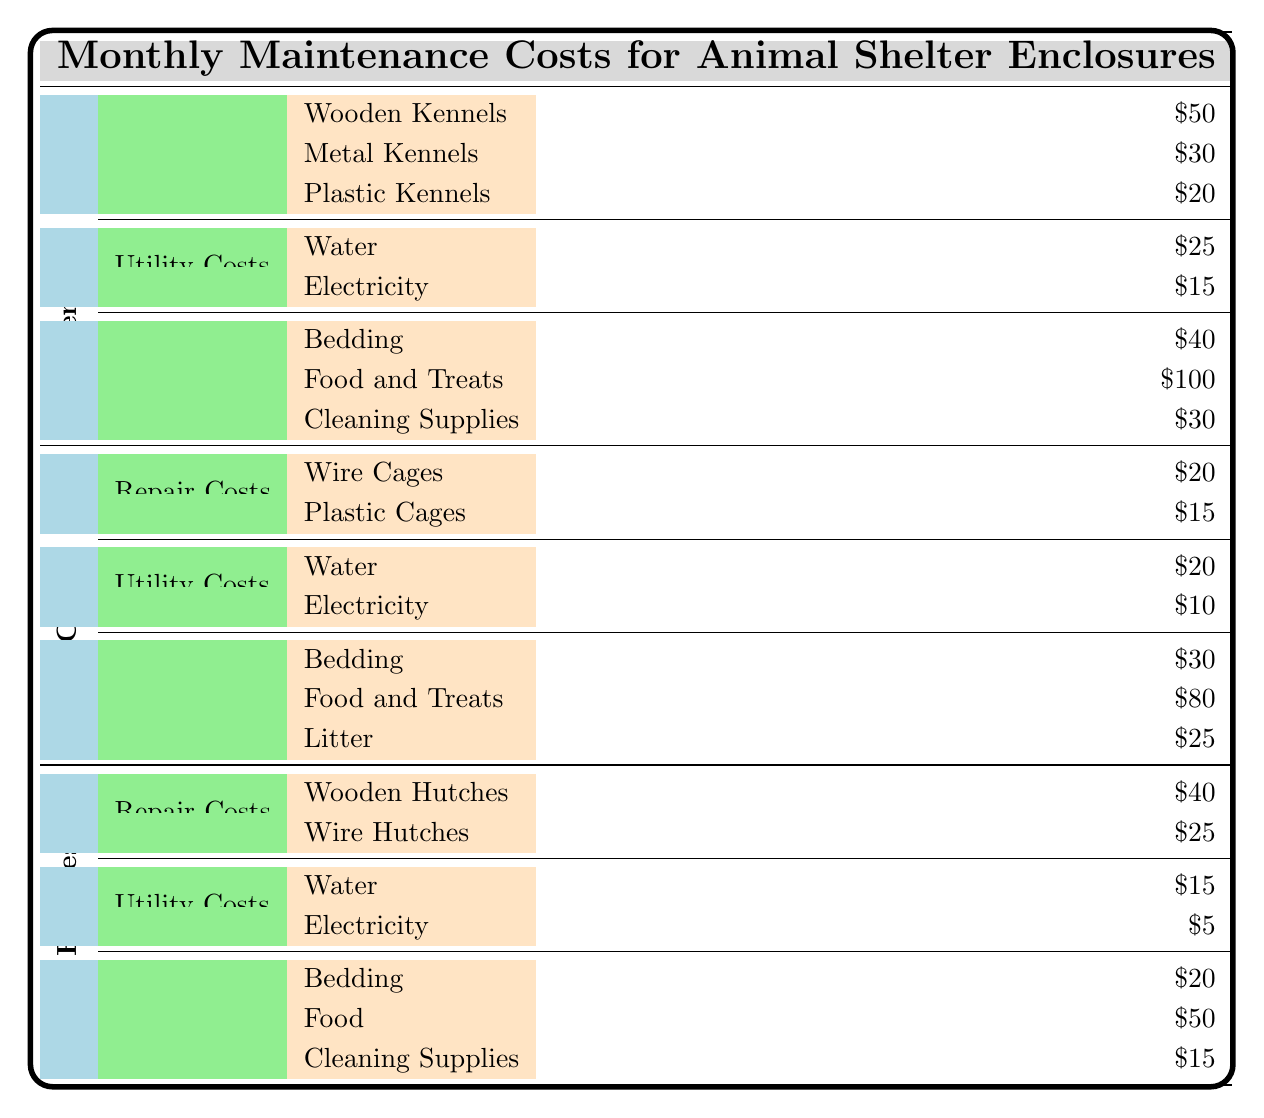What are the repair costs for Wooden Kennels? The repair cost for Wooden Kennels is listed directly in the table under Dog Kennels, specifically as $50.
Answer: $50 What is the total Utility Cost for Cat Cages? To find the total Utility Cost for Cat Cages, we add the Water cost of $20 and Electricity cost of $10. This gives us a total of $30.
Answer: $30 Are there any Plastic Cages in the repair costs for Cat Cages? Yes, there is a cost listed for Plastic Cages, specifically $15, indicating that they are included in the repair costs.
Answer: Yes What is the average supplies cost for Rabbit Hutches? The supplies costs for Rabbit Hutches are listed as Bedding $20, Food $50, and Cleaning Supplies $15. First, we sum these values (20 + 50 + 15 = 85). Then, we divide this total by 3 (the number of supplies) to get the average, which is $85/3 = approximately $28.33.
Answer: $28.33 What is the total monthly maintenance cost for Dog Kennels? To find the total monthly maintenance cost for Dog Kennels, we need to sum all cost categories: Repair Costs ($50 + $30 + $20 = $100), Utility Costs ($25 + $15 = $40), and Supplies ($40 + $100 + $30 = $170). Adding these gives us $100 + $40 + $170 = $310.
Answer: $310 How much do the repair costs for all types of enclosures add up to? To determine the total repair costs, we need to sum the costs from all enclosures: Dog Kennels ($100), Cat Cages ($35), and Rabbit Hutches ($65). So, the total is $100 + $35 + $65 = $200.
Answer: $200 Is the utility cost for Water in Rabbit Hutches lower than that in Dog Kennels? Yes, the utility cost for Water in Rabbit Hutches is $15, which is lower than the $25 for Dog Kennels.
Answer: Yes What is the highest supply cost among different types of enclosures? The supply costs are: Dog Kennels ($100), Cat Cages ($80), and Rabbit Hutches ($50). The highest among these is $100 for Food and Treats in Dog Kennels.
Answer: $100 